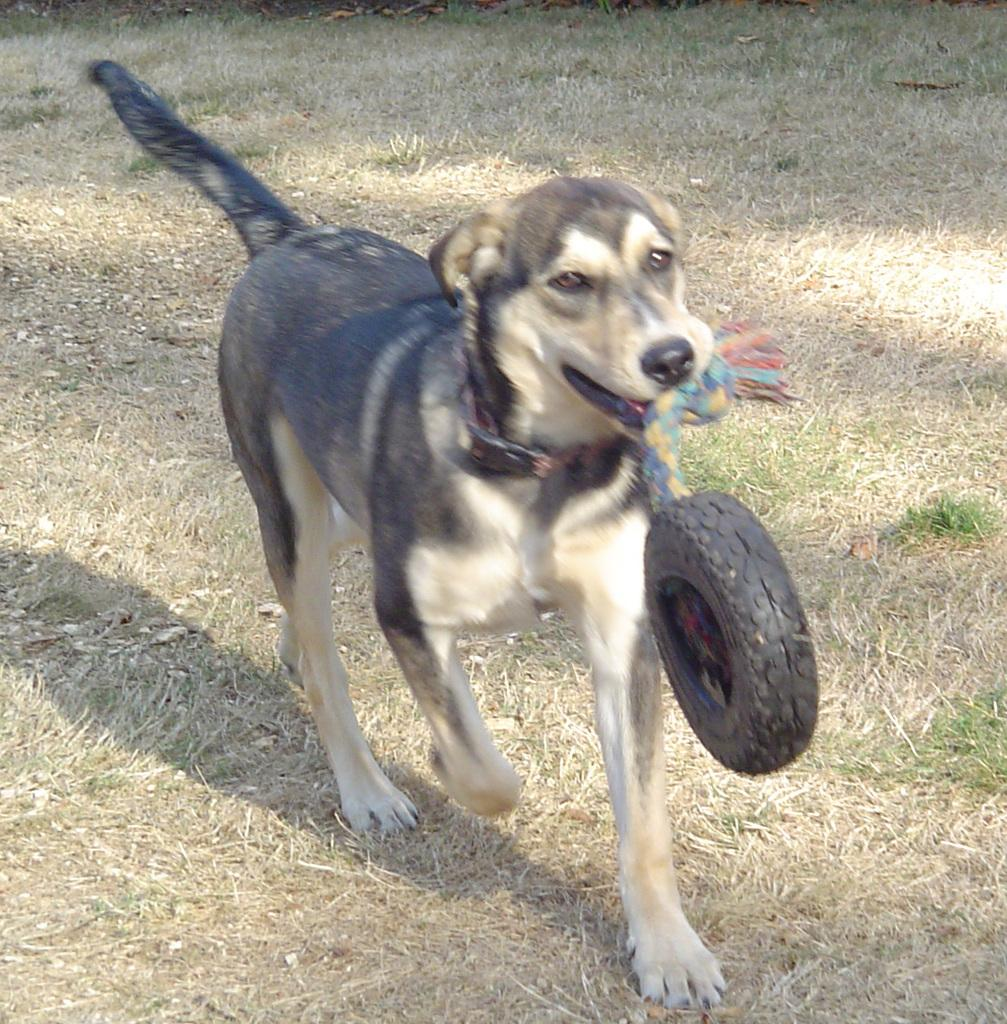What animal can be seen in the image? There is a dog in the image. What is the dog doing in the image? The dog is running in the image. What is the dog holding in its mouth? The dog is holding a tire in its mouth. What type of terrain is visible in the image? There is dry grass on the ground in the image. What type of engine can be seen powering the dog in the image? There is no engine present in the image; the dog is running on its own. What type of lock is visible on the tire the dog is holding in its mouth? There is no lock visible on the tire the dog is holding in its mouth. 